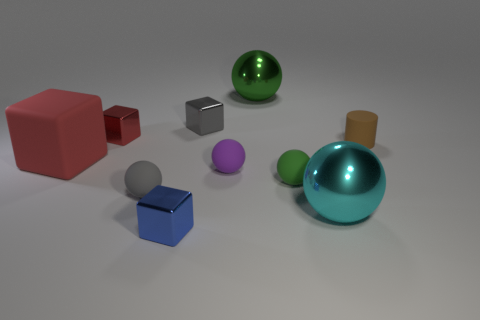Is there another object that has the same color as the big rubber thing?
Provide a succinct answer. Yes. There is a big shiny ball that is to the right of the big sphere that is to the left of the green matte object; what is its color?
Your response must be concise. Cyan. There is a metallic ball that is behind the big cyan sphere; what is its size?
Offer a very short reply. Large. Is there a green object that has the same material as the brown cylinder?
Provide a short and direct response. Yes. How many purple things have the same shape as the gray metallic thing?
Give a very brief answer. 0. There is a big thing behind the metallic cube on the left side of the tiny metal cube that is in front of the big rubber block; what shape is it?
Your response must be concise. Sphere. What is the tiny object that is both behind the tiny green object and to the left of the tiny blue metallic cube made of?
Provide a short and direct response. Metal. There is a sphere that is behind the purple ball; is it the same size as the gray rubber object?
Give a very brief answer. No. Are there more matte objects to the left of the red shiny block than red cubes behind the large rubber object?
Your answer should be compact. No. The tiny metal block on the left side of the metal thing in front of the big sphere in front of the large red object is what color?
Provide a succinct answer. Red. 